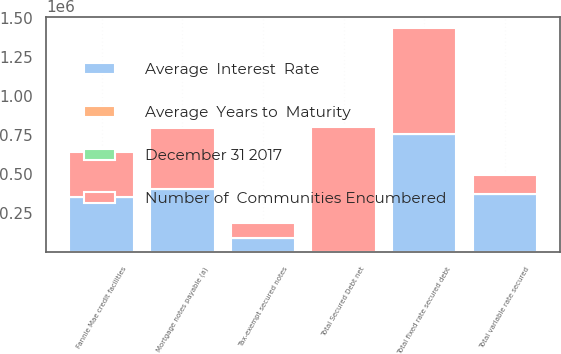Convert chart. <chart><loc_0><loc_0><loc_500><loc_500><stacked_bar_chart><ecel><fcel>Mortgage notes payable (a)<fcel>Fannie Mae credit facilities<fcel>Total fixed rate secured debt<fcel>Tax-exempt secured notes<fcel>Total variable rate secured<fcel>Total Secured Debt net<nl><fcel>Number of  Communities Encumbered<fcel>395611<fcel>285836<fcel>679777<fcel>94700<fcel>123492<fcel>803269<nl><fcel>Average  Interest  Rate<fcel>402996<fcel>355836<fcel>756151<fcel>94700<fcel>374707<fcel>5.3<nl><fcel>Average  Years to  Maturity<fcel>4.04<fcel>4.86<fcel>4.39<fcel>1.9<fcel>2.14<fcel>4.04<nl><fcel>December 31 2017<fcel>5.3<fcel>2<fcel>3.9<fcel>5.2<fcel>4.2<fcel>4<nl></chart> 